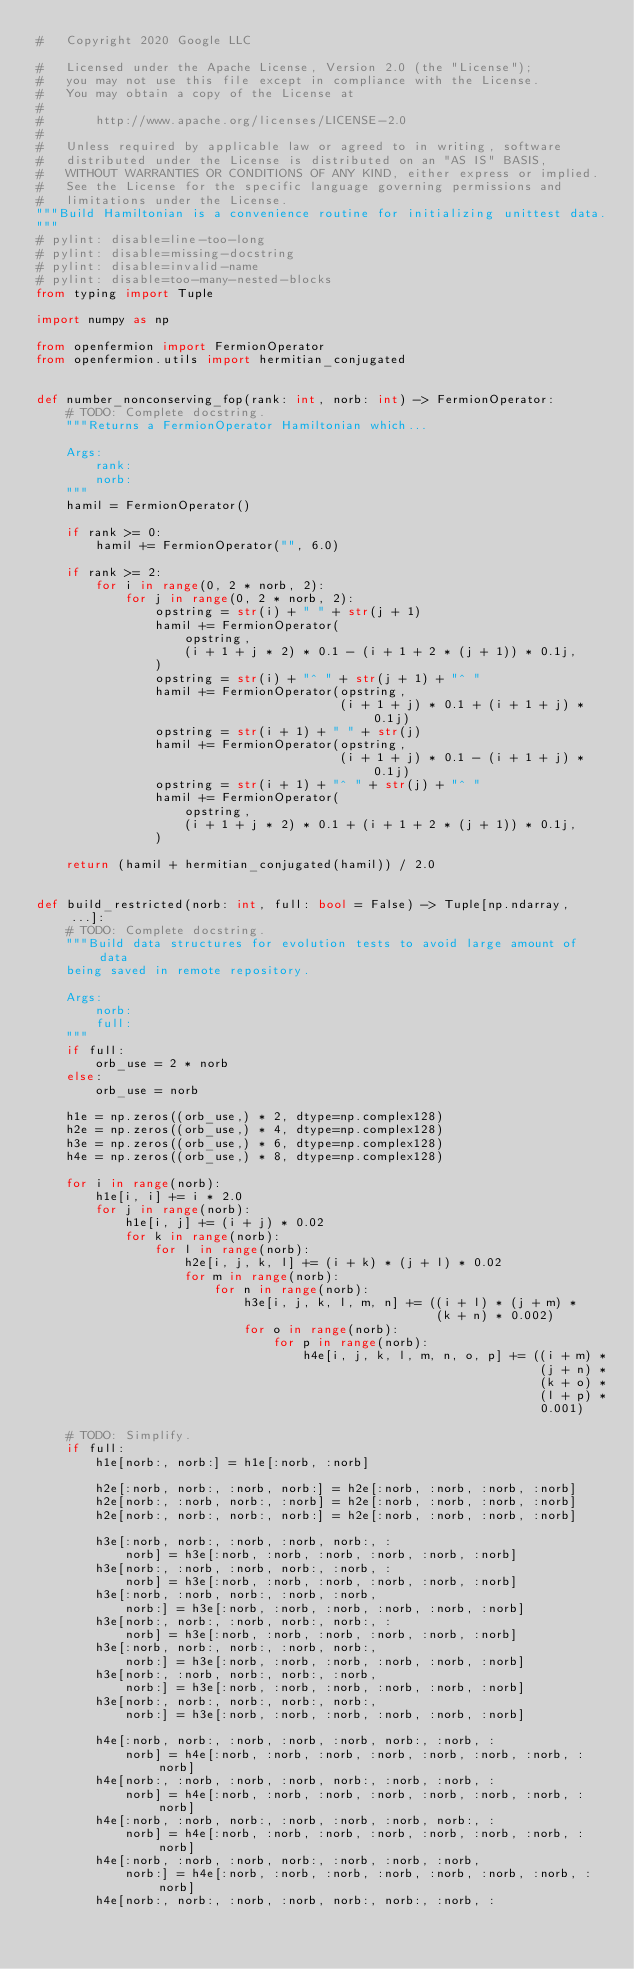Convert code to text. <code><loc_0><loc_0><loc_500><loc_500><_Python_>#   Copyright 2020 Google LLC

#   Licensed under the Apache License, Version 2.0 (the "License");
#   you may not use this file except in compliance with the License.
#   You may obtain a copy of the License at
#
#       http://www.apache.org/licenses/LICENSE-2.0
#
#   Unless required by applicable law or agreed to in writing, software
#   distributed under the License is distributed on an "AS IS" BASIS,
#   WITHOUT WARRANTIES OR CONDITIONS OF ANY KIND, either express or implied.
#   See the License for the specific language governing permissions and
#   limitations under the License.
"""Build Hamiltonian is a convenience routine for initializing unittest data.
"""
# pylint: disable=line-too-long
# pylint: disable=missing-docstring
# pylint: disable=invalid-name
# pylint: disable=too-many-nested-blocks
from typing import Tuple

import numpy as np

from openfermion import FermionOperator
from openfermion.utils import hermitian_conjugated


def number_nonconserving_fop(rank: int, norb: int) -> FermionOperator:
    # TODO: Complete docstring.
    """Returns a FermionOperator Hamiltonian which...

    Args:
        rank:
        norb:
    """
    hamil = FermionOperator()

    if rank >= 0:
        hamil += FermionOperator("", 6.0)

    if rank >= 2:
        for i in range(0, 2 * norb, 2):
            for j in range(0, 2 * norb, 2):
                opstring = str(i) + " " + str(j + 1)
                hamil += FermionOperator(
                    opstring,
                    (i + 1 + j * 2) * 0.1 - (i + 1 + 2 * (j + 1)) * 0.1j,
                )
                opstring = str(i) + "^ " + str(j + 1) + "^ "
                hamil += FermionOperator(opstring,
                                         (i + 1 + j) * 0.1 + (i + 1 + j) * 0.1j)
                opstring = str(i + 1) + " " + str(j)
                hamil += FermionOperator(opstring,
                                         (i + 1 + j) * 0.1 - (i + 1 + j) * 0.1j)
                opstring = str(i + 1) + "^ " + str(j) + "^ "
                hamil += FermionOperator(
                    opstring,
                    (i + 1 + j * 2) * 0.1 + (i + 1 + 2 * (j + 1)) * 0.1j,
                )

    return (hamil + hermitian_conjugated(hamil)) / 2.0


def build_restricted(norb: int, full: bool = False) -> Tuple[np.ndarray, ...]:
    # TODO: Complete docstring.
    """Build data structures for evolution tests to avoid large amount of data
    being saved in remote repository.

    Args:
        norb:
        full:
    """
    if full:
        orb_use = 2 * norb
    else:
        orb_use = norb

    h1e = np.zeros((orb_use,) * 2, dtype=np.complex128)
    h2e = np.zeros((orb_use,) * 4, dtype=np.complex128)
    h3e = np.zeros((orb_use,) * 6, dtype=np.complex128)
    h4e = np.zeros((orb_use,) * 8, dtype=np.complex128)

    for i in range(norb):
        h1e[i, i] += i * 2.0
        for j in range(norb):
            h1e[i, j] += (i + j) * 0.02
            for k in range(norb):
                for l in range(norb):
                    h2e[i, j, k, l] += (i + k) * (j + l) * 0.02
                    for m in range(norb):
                        for n in range(norb):
                            h3e[i, j, k, l, m, n] += ((i + l) * (j + m) *
                                                      (k + n) * 0.002)
                            for o in range(norb):
                                for p in range(norb):
                                    h4e[i, j, k, l, m, n, o, p] += ((i + m) *
                                                                    (j + n) *
                                                                    (k + o) *
                                                                    (l + p) *
                                                                    0.001)

    # TODO: Simplify.
    if full:
        h1e[norb:, norb:] = h1e[:norb, :norb]

        h2e[:norb, norb:, :norb, norb:] = h2e[:norb, :norb, :norb, :norb]
        h2e[norb:, :norb, norb:, :norb] = h2e[:norb, :norb, :norb, :norb]
        h2e[norb:, norb:, norb:, norb:] = h2e[:norb, :norb, :norb, :norb]

        h3e[:norb, norb:, :norb, :norb, norb:, :
            norb] = h3e[:norb, :norb, :norb, :norb, :norb, :norb]
        h3e[norb:, :norb, :norb, norb:, :norb, :
            norb] = h3e[:norb, :norb, :norb, :norb, :norb, :norb]
        h3e[:norb, :norb, norb:, :norb, :norb,
            norb:] = h3e[:norb, :norb, :norb, :norb, :norb, :norb]
        h3e[norb:, norb:, :norb, norb:, norb:, :
            norb] = h3e[:norb, :norb, :norb, :norb, :norb, :norb]
        h3e[:norb, norb:, norb:, :norb, norb:,
            norb:] = h3e[:norb, :norb, :norb, :norb, :norb, :norb]
        h3e[norb:, :norb, norb:, norb:, :norb,
            norb:] = h3e[:norb, :norb, :norb, :norb, :norb, :norb]
        h3e[norb:, norb:, norb:, norb:, norb:,
            norb:] = h3e[:norb, :norb, :norb, :norb, :norb, :norb]

        h4e[:norb, norb:, :norb, :norb, :norb, norb:, :norb, :
            norb] = h4e[:norb, :norb, :norb, :norb, :norb, :norb, :norb, :norb]
        h4e[norb:, :norb, :norb, :norb, norb:, :norb, :norb, :
            norb] = h4e[:norb, :norb, :norb, :norb, :norb, :norb, :norb, :norb]
        h4e[:norb, :norb, norb:, :norb, :norb, :norb, norb:, :
            norb] = h4e[:norb, :norb, :norb, :norb, :norb, :norb, :norb, :norb]
        h4e[:norb, :norb, :norb, norb:, :norb, :norb, :norb,
            norb:] = h4e[:norb, :norb, :norb, :norb, :norb, :norb, :norb, :norb]
        h4e[norb:, norb:, :norb, :norb, norb:, norb:, :norb, :</code> 